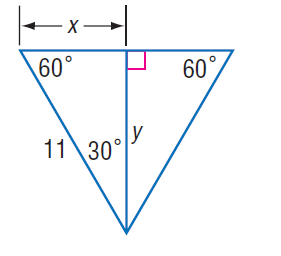Question: Find x.
Choices:
A. 5.5
B. 5.5 \sqrt { 2 }
C. 11
D. 11 \sqrt { 2 }
Answer with the letter. Answer: A 